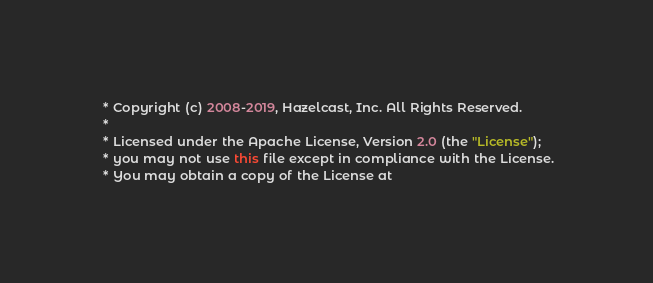<code> <loc_0><loc_0><loc_500><loc_500><_Java_> * Copyright (c) 2008-2019, Hazelcast, Inc. All Rights Reserved.
 *
 * Licensed under the Apache License, Version 2.0 (the "License");
 * you may not use this file except in compliance with the License.
 * You may obtain a copy of the License at</code> 